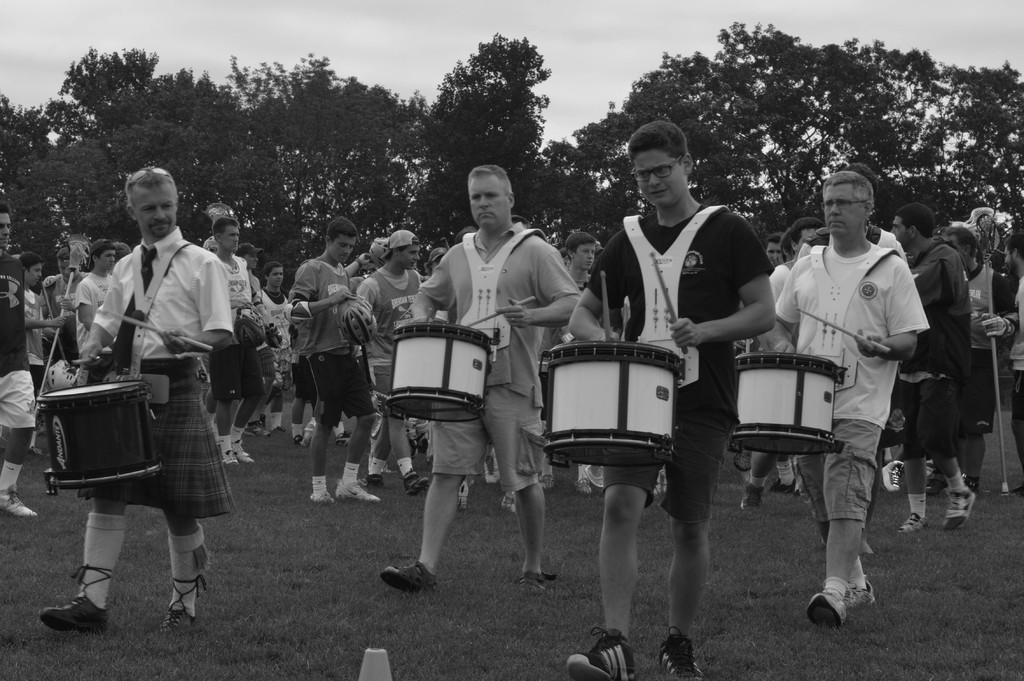Can you describe this image briefly? In this image I can see number of people were few of them are holding drums. In the background I can see few more trees. 